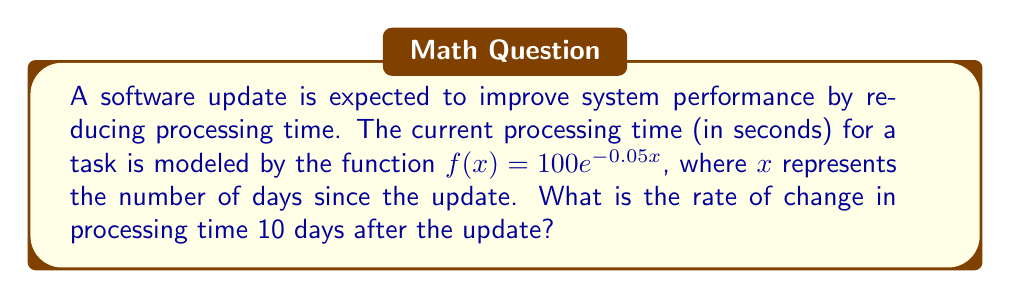Provide a solution to this math problem. To find the rate of change in processing time 10 days after the update, we need to calculate the derivative of the given function and evaluate it at x = 10.

Step 1: Find the derivative of $f(x) = 100e^{-0.05x}$
Using the chain rule, we get:
$$f'(x) = 100 \cdot (-0.05) \cdot e^{-0.05x} = -5e^{-0.05x}$$

Step 2: Evaluate $f'(x)$ at x = 10
$$f'(10) = -5e^{-0.05 \cdot 10} = -5e^{-0.5}$$

Step 3: Calculate the final value
$$f'(10) = -5 \cdot 0.6065 \approx -3.0325$$

The negative value indicates that the processing time is decreasing at a rate of approximately 3.0325 seconds per day, 10 days after the update.
Answer: $-3.0325$ seconds per day 